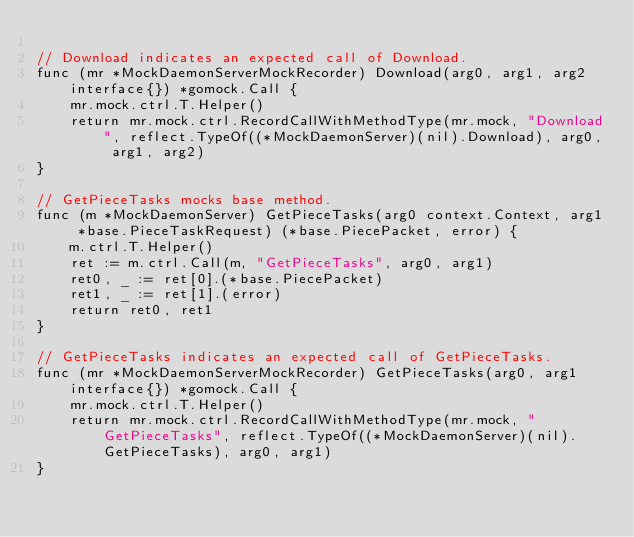Convert code to text. <code><loc_0><loc_0><loc_500><loc_500><_Go_>
// Download indicates an expected call of Download.
func (mr *MockDaemonServerMockRecorder) Download(arg0, arg1, arg2 interface{}) *gomock.Call {
	mr.mock.ctrl.T.Helper()
	return mr.mock.ctrl.RecordCallWithMethodType(mr.mock, "Download", reflect.TypeOf((*MockDaemonServer)(nil).Download), arg0, arg1, arg2)
}

// GetPieceTasks mocks base method.
func (m *MockDaemonServer) GetPieceTasks(arg0 context.Context, arg1 *base.PieceTaskRequest) (*base.PiecePacket, error) {
	m.ctrl.T.Helper()
	ret := m.ctrl.Call(m, "GetPieceTasks", arg0, arg1)
	ret0, _ := ret[0].(*base.PiecePacket)
	ret1, _ := ret[1].(error)
	return ret0, ret1
}

// GetPieceTasks indicates an expected call of GetPieceTasks.
func (mr *MockDaemonServerMockRecorder) GetPieceTasks(arg0, arg1 interface{}) *gomock.Call {
	mr.mock.ctrl.T.Helper()
	return mr.mock.ctrl.RecordCallWithMethodType(mr.mock, "GetPieceTasks", reflect.TypeOf((*MockDaemonServer)(nil).GetPieceTasks), arg0, arg1)
}
</code> 